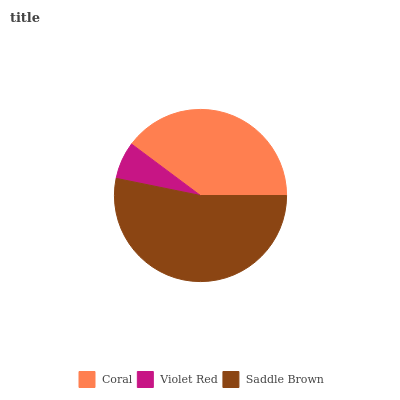Is Violet Red the minimum?
Answer yes or no. Yes. Is Saddle Brown the maximum?
Answer yes or no. Yes. Is Saddle Brown the minimum?
Answer yes or no. No. Is Violet Red the maximum?
Answer yes or no. No. Is Saddle Brown greater than Violet Red?
Answer yes or no. Yes. Is Violet Red less than Saddle Brown?
Answer yes or no. Yes. Is Violet Red greater than Saddle Brown?
Answer yes or no. No. Is Saddle Brown less than Violet Red?
Answer yes or no. No. Is Coral the high median?
Answer yes or no. Yes. Is Coral the low median?
Answer yes or no. Yes. Is Violet Red the high median?
Answer yes or no. No. Is Violet Red the low median?
Answer yes or no. No. 